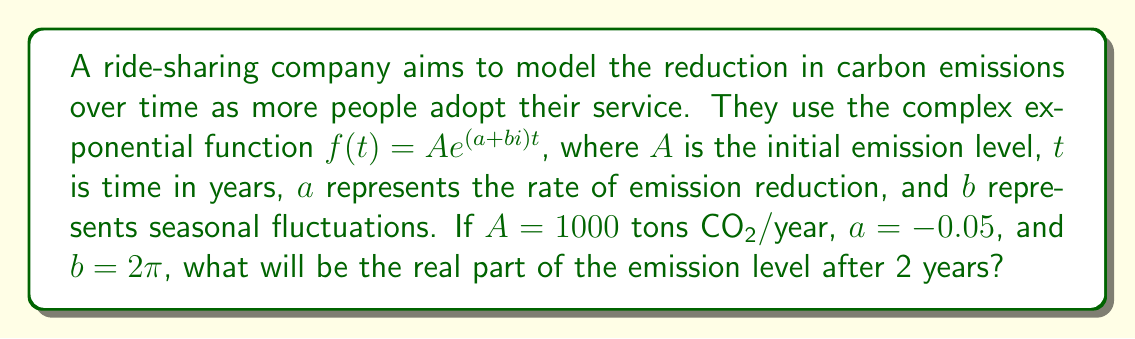Can you answer this question? Let's approach this step-by-step:

1) We're given the function $f(t) = Ae^{(a+bi)t}$ with:
   $A = 1000$, $a = -0.05$, $b = 2\pi$, and we need to find the value for $t = 2$.

2) Substituting these values into the function:
   $f(2) = 1000e^{(-0.05+2\pi i)2}$

3) Simplify the exponent:
   $f(2) = 1000e^{-0.1+4\pi i}$

4) We can rewrite this using Euler's formula: $e^{ix} = \cos x + i\sin x$
   $f(2) = 1000e^{-0.1}(\cos(4\pi) + i\sin(4\pi))$

5) Simplify $e^{-0.1}$:
   $e^{-0.1} \approx 0.9048$

6) Note that $\cos(4\pi) = 1$ and $\sin(4\pi) = 0$

7) Therefore:
   $f(2) = 1000 \cdot 0.9048 \cdot (1 + 0i) = 904.8$

8) The real part of this complex number is 904.8.
Answer: 904.8 tons CO₂/year 